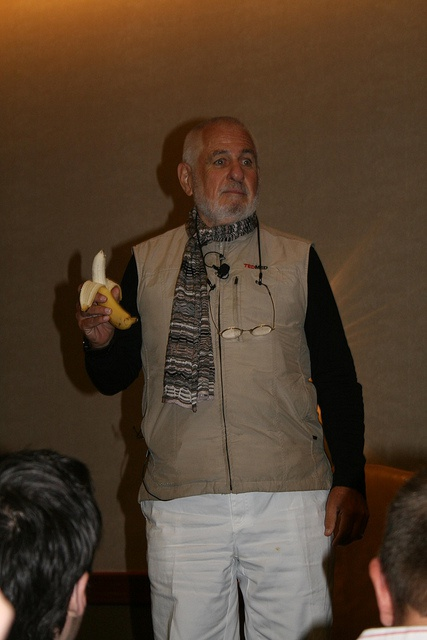Describe the objects in this image and their specific colors. I can see people in red, gray, black, darkgray, and maroon tones, people in red, black, and gray tones, people in red, black, maroon, lightgray, and brown tones, and banana in red, olive, tan, and maroon tones in this image. 